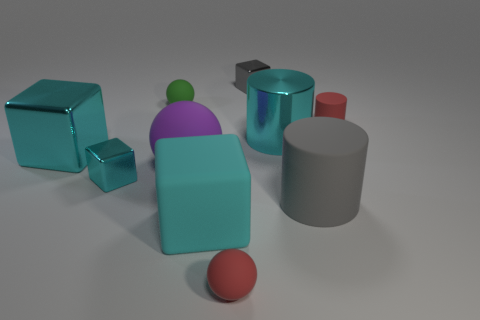Is there a big cyan shiny cube that is on the left side of the tiny red matte sphere in front of the small sphere behind the purple matte ball?
Ensure brevity in your answer.  Yes. How many other objects are there of the same color as the large metallic cube?
Offer a terse response. 3. How many small objects are both to the right of the big gray rubber cylinder and behind the small green rubber object?
Ensure brevity in your answer.  0. There is a purple matte thing; what shape is it?
Your answer should be compact. Sphere. What number of other things are the same material as the small red ball?
Your answer should be compact. 5. The small metal block on the left side of the tiny matte thing in front of the cylinder to the right of the large rubber cylinder is what color?
Give a very brief answer. Cyan. What is the material of the gray cylinder that is the same size as the matte cube?
Provide a succinct answer. Rubber. What number of things are either big cylinders that are behind the purple matte object or large cyan objects?
Provide a succinct answer. 3. Is there a large blue sphere?
Your response must be concise. No. There is a large cylinder that is on the right side of the large metallic cylinder; what is it made of?
Offer a terse response. Rubber. 